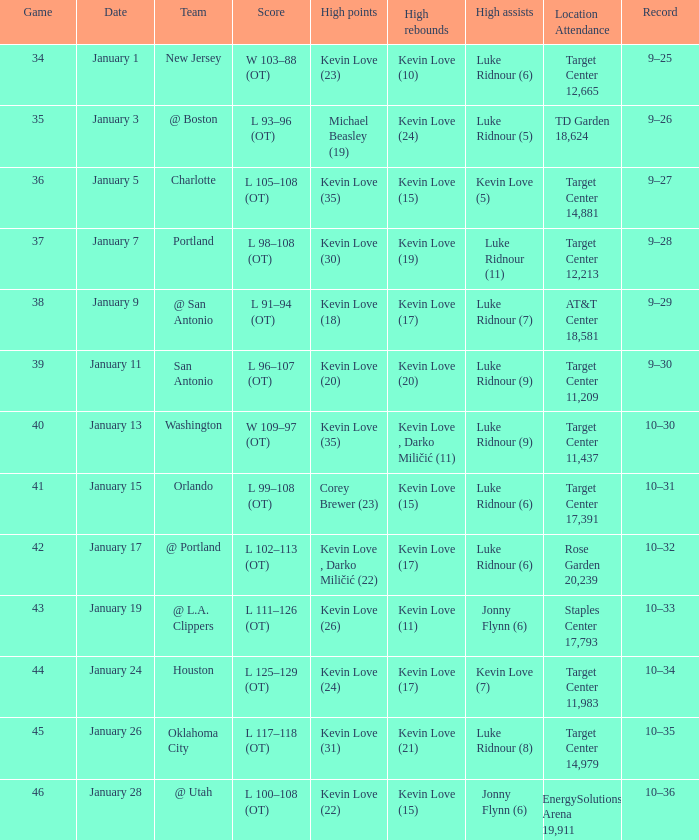What is the top game with team @ l.a. clippers? 43.0. 